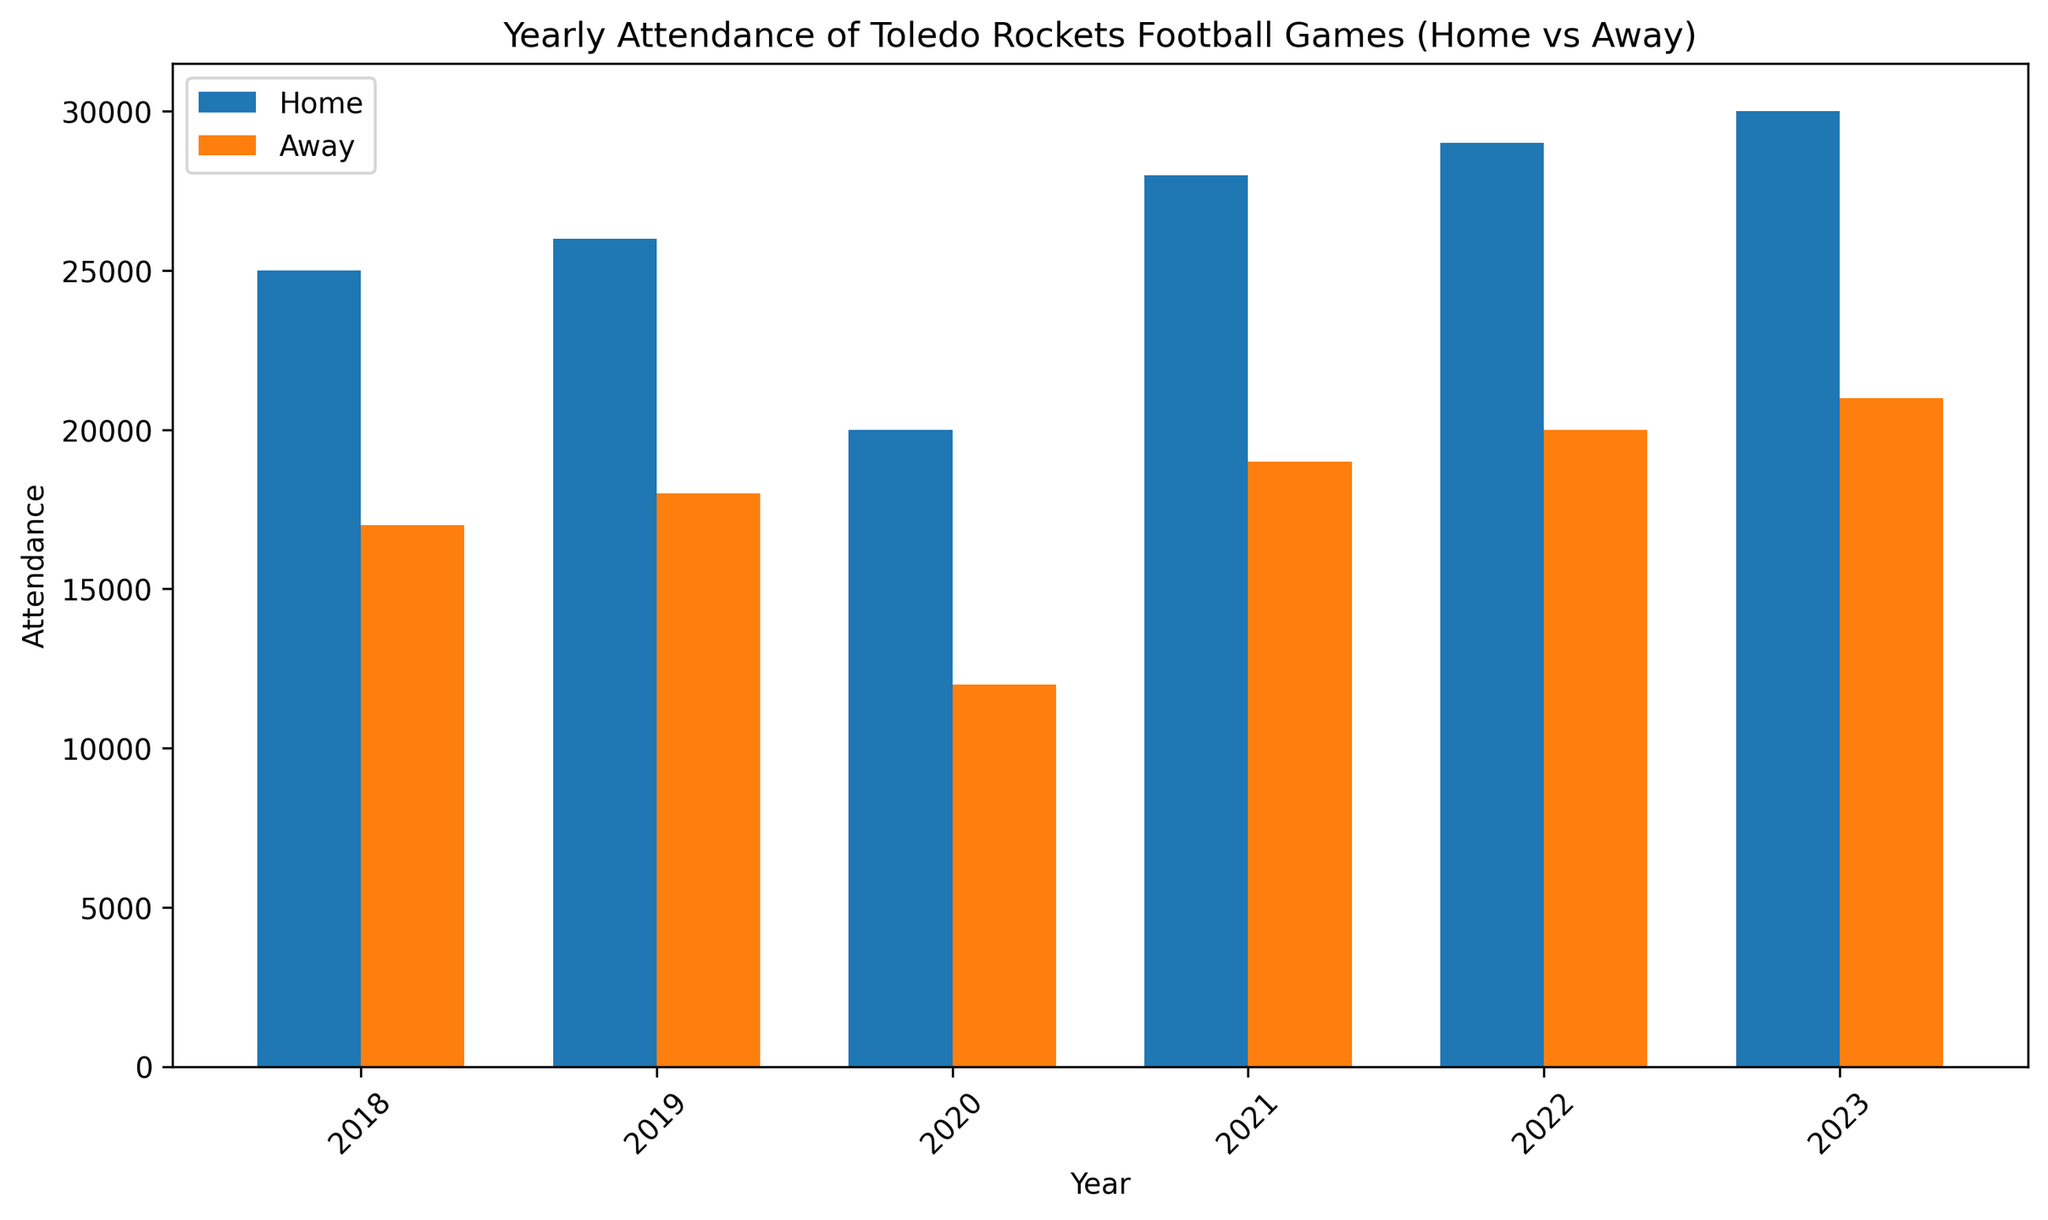Which year had the highest total attendance for home games? To find the year with the highest total attendance for home games, look at the heights of the blue bars (home games) and identify the tallest bar. The tallest blue bar corresponds to the year 2023.
Answer: 2023 In which year was the attendance difference between home and away games the largest? Calculate the attendance difference for each year by subtracting the away game attendance from the home game attendance. The largest difference is found in the year 2020 (20000 - 12000 = 8000).
Answer: 2020 What is the average attendance for away games over the years shown in the bar plot? Sum the attendance values for away games: 17000 + 18000 + 12000 + 19000 + 20000 + 21000 = 107000. Divide this sum by the number of years (6): 107000 / 6 = 17833.33
Answer: 17833.33 Which game type had a higher attendance in 2019, home or away? Compare the heights of the bars for the year 2019. The blue bar (home) is higher than the orange bar (away), indicating higher attendance for home games in 2019.
Answer: Home How much lower was the lowest home game attendance compared to the highest home game attendance? The lowest home game attendance is in 2020 (20000) and the highest is in 2023 (30000). Subtract the lowest attendance from the highest: 30000 - 20000 = 10000.
Answer: 10000 In which year did the attendance for away games show the largest increase from the previous year? Observe the orange bars and calculate the difference year over year. The largest increase is between 2020 and 2021 (19000 - 12000 = 7000).
Answer: 2021 Are there any years where the attendance for home and away games was equal? Compare the heights of blue and orange bars for each year. There are no years where the home and away game attendances are equal.
Answer: No Which game type shows a generally increasing trend in attendance over the years? Observe the patterns in bar heights for each game type. Blue bars (home games) show a steady increase in height from 2018 to 2023, indicating an increasing trend.
Answer: Home 